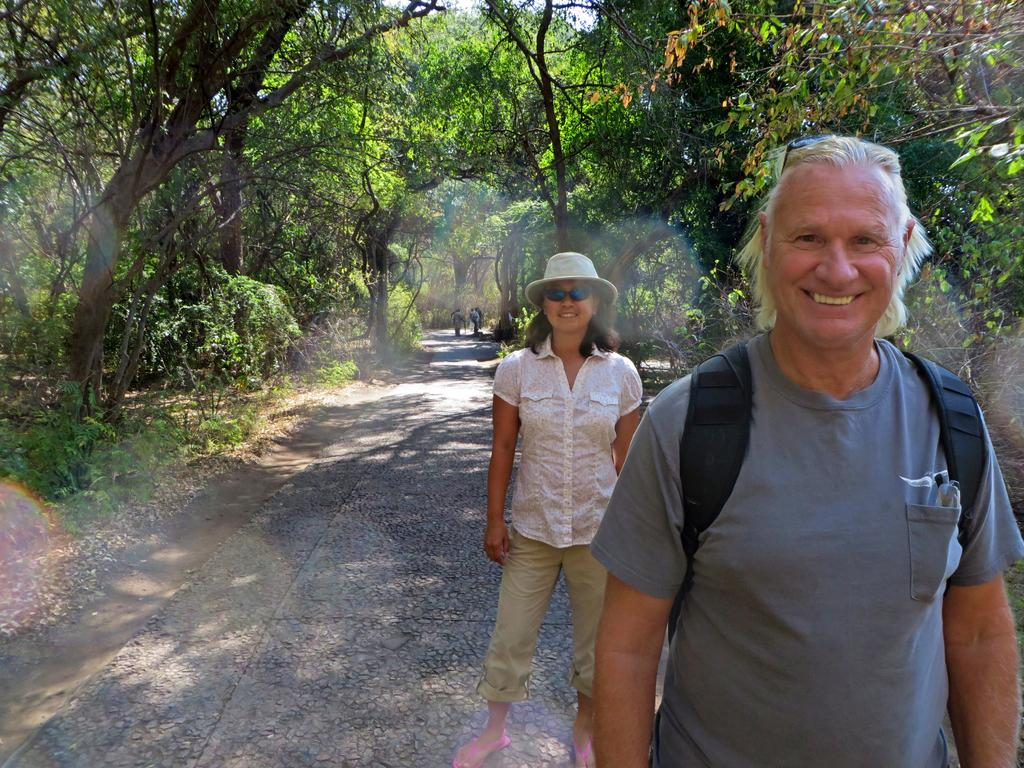Who can be seen in the image? There is a man and a woman in the image. What are the man and woman doing in the image? Both the man and woman are on a path. Can you describe the background of the image? There are a few people visible in the background, along with plants and trees. What type of blood is visible on the man's shirt in the image? There is no blood visible on the man's shirt in the image. How many passengers are present in the image? The term "passenger" is not applicable in this context, as there are no vehicles or transportation-related elements in the image. 